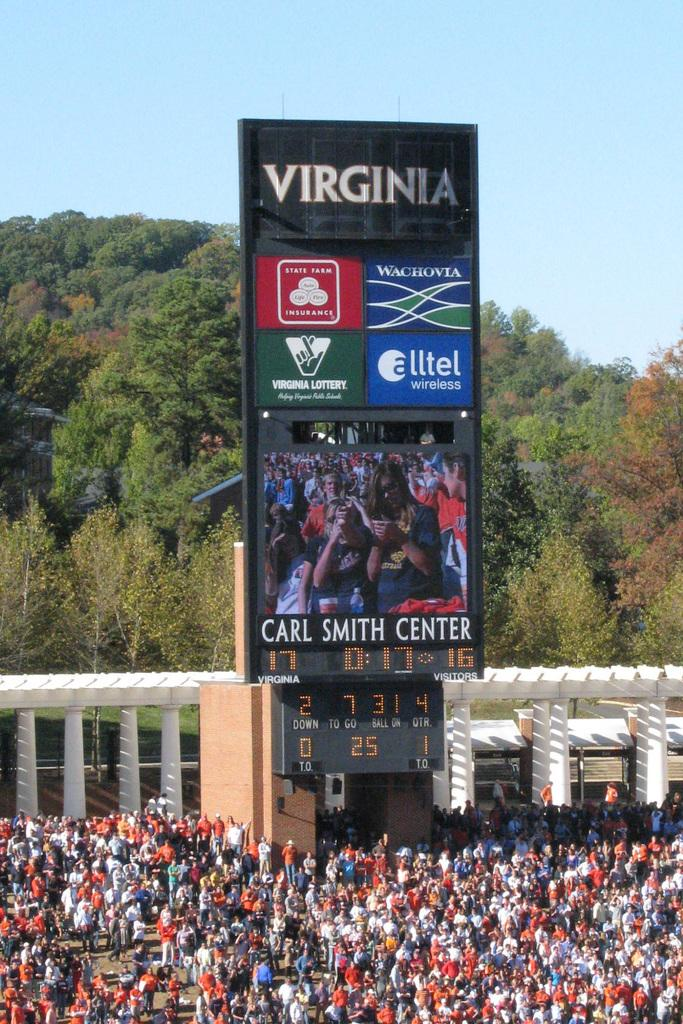<image>
Give a short and clear explanation of the subsequent image. Bunch of people watching a game in Virgina 